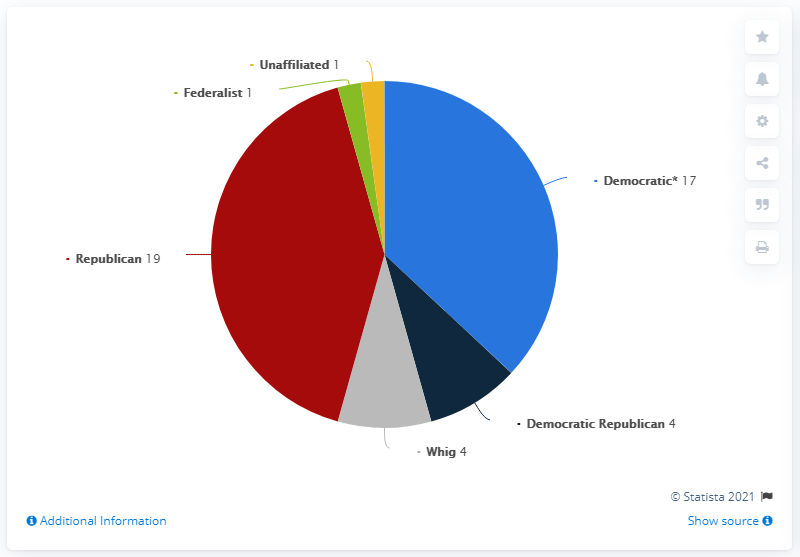Specify some key components in this picture. Thirty-six American presidents have served either as Democrats or Republicans. Since 1789, there have been one U.S. president who was a Federalist. 